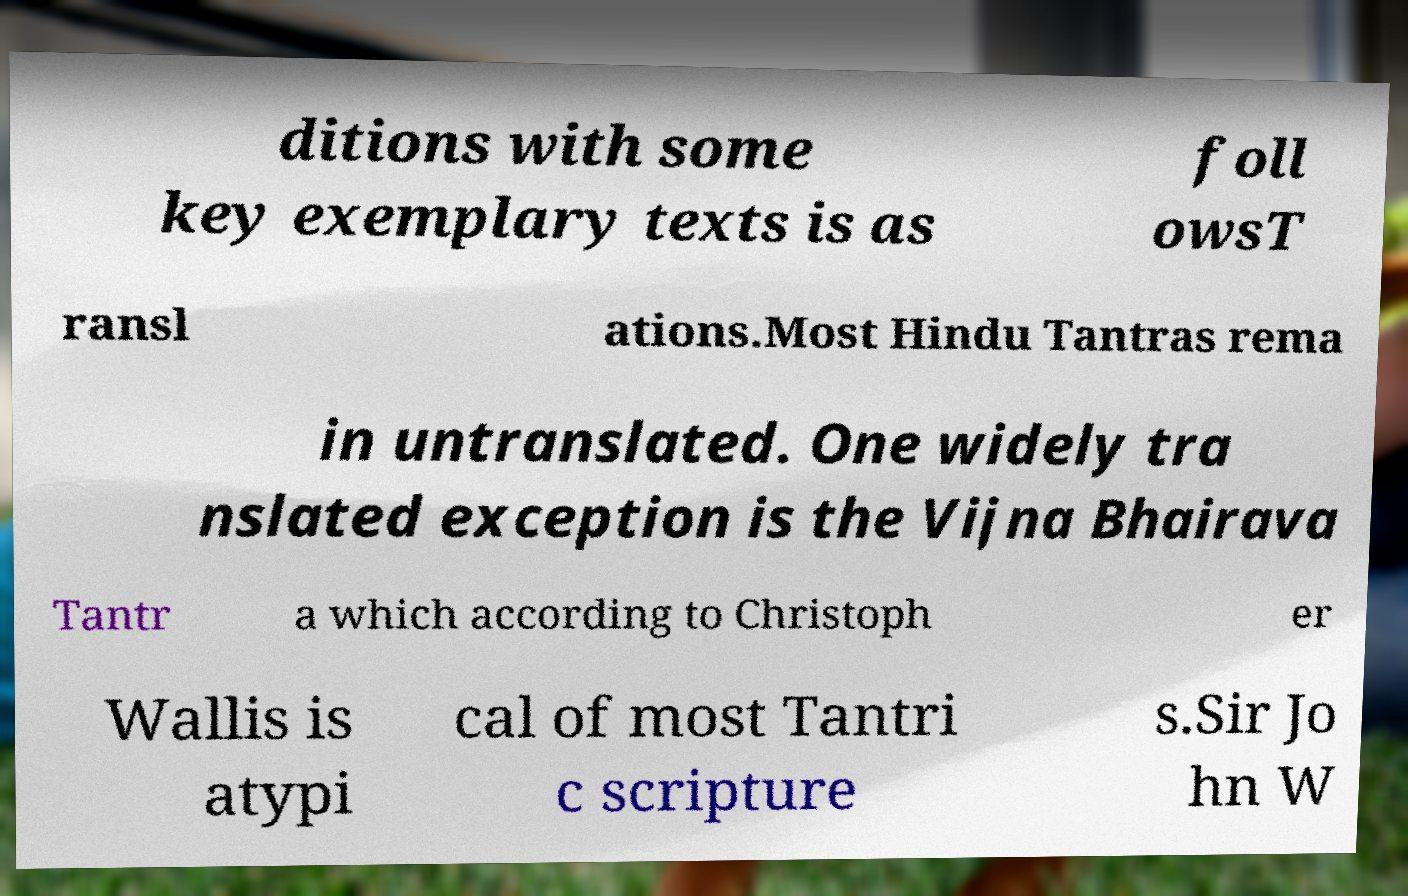Could you extract and type out the text from this image? ditions with some key exemplary texts is as foll owsT ransl ations.Most Hindu Tantras rema in untranslated. One widely tra nslated exception is the Vijna Bhairava Tantr a which according to Christoph er Wallis is atypi cal of most Tantri c scripture s.Sir Jo hn W 